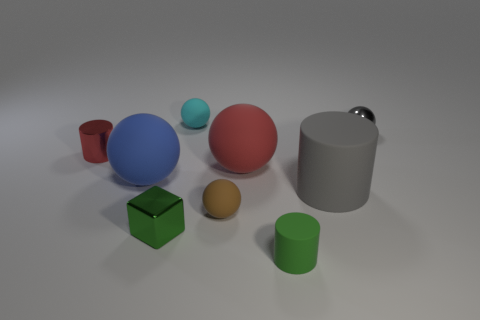There is a large matte object to the left of the small matte object behind the small red shiny thing; are there any small green matte things on the left side of it?
Your response must be concise. No. The metal cylinder is what color?
Provide a succinct answer. Red. What color is the matte cylinder that is the same size as the gray metal object?
Provide a short and direct response. Green. Do the tiny thing in front of the tiny metal cube and the tiny green metallic object have the same shape?
Keep it short and to the point. No. What color is the small cylinder left of the tiny rubber sphere that is behind the small shiny object that is behind the tiny shiny cylinder?
Offer a terse response. Red. Is there a big green matte ball?
Provide a succinct answer. No. What number of other things are there of the same size as the green matte object?
Make the answer very short. 5. There is a cube; does it have the same color as the rubber cylinder that is behind the small block?
Provide a succinct answer. No. How many objects are either large rubber cylinders or tiny cyan rubber things?
Make the answer very short. 2. Is there anything else that is the same color as the block?
Keep it short and to the point. Yes. 